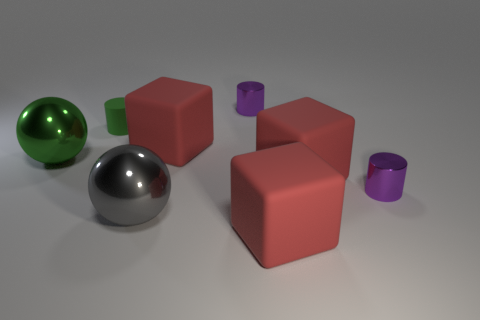Add 1 big red shiny cylinders. How many objects exist? 9 Subtract all cubes. How many objects are left? 5 Subtract all tiny objects. Subtract all gray shiny spheres. How many objects are left? 4 Add 5 green metallic balls. How many green metallic balls are left? 6 Add 5 small cylinders. How many small cylinders exist? 8 Subtract 0 gray cubes. How many objects are left? 8 